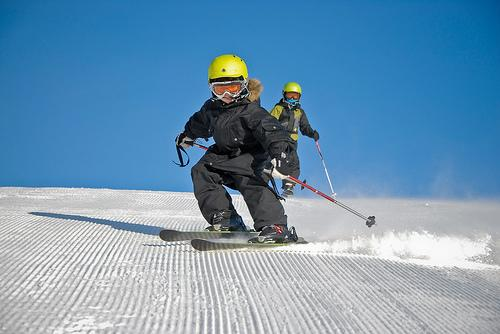What type of sport are the two people engaging in, and which of them appears to be wearing a neon-colored helmet? The two people are skiing, and the person with blue-rimmed goggles appears to be wearing a neon-colored helmet. Provide a detailed description of the skiwear of the person in the center of the image. The person is wearing a yellow helmet, white-rimmed goggles, a black coat with a fur-trimmed hood, and black snow pants, holding red and silver ski poles with gray accents. Assess the quality of the image based on the detail of the objects and the overall visual impact. The image is of high quality, with many detailed objects such as the fur lining on coat hoods, goggles, and a variety of ski equipment, in a well-lit and visually cohesive scene. Identify the safety gear worn by the two children skiing in this image. Both children are wearing helmets, one yellow and the other neon-colored, and both are wearing goggles, one with white rims and the other with blue rims. Analyze the emotions that the subjects in the image may be experiencing based on their body posture, attire, and overall situation. The skiers, likely children, are probably experiencing excitement, enjoyment, and adventure, while skiing down the mountainside in their protective gear under the clear blue sky. How many people are skiing in the image, and what is the condition of the snow terrain? There are two people skiing, and the snow condition has lines, ridges, and snow dust being kicked up as the skiers carve through the groomed terrain. Count the number of ski poles and goggles featured in the image. There are four ski poles, two red and silver with gray accents, plus a few red ones, and three pairs of goggles, one white-rimmed, one blue-rimmed, and one orange. Explain the interaction between the skiers and the snow terrain in the image. The skiers are carving through the groomed snow, creating lines and ridges on the terrain, and they also generate a spray of snow dust as they swiftly ski down the slope. What is the color of the sky and what does it indicate about the weather? The sky is clear and deep blue, indicating good weather conditions for skiing, likely with comfortable temperatures and plenty of sunshine. Deduce the reasoning behind the black pocket on the sleeve, considering its potential function in the context of skiing. The black pocket on the sleeve may have a practical function, such as offering storage space for small items like an RFID ski pass, or providing additional insulation to keep the skier warm. 